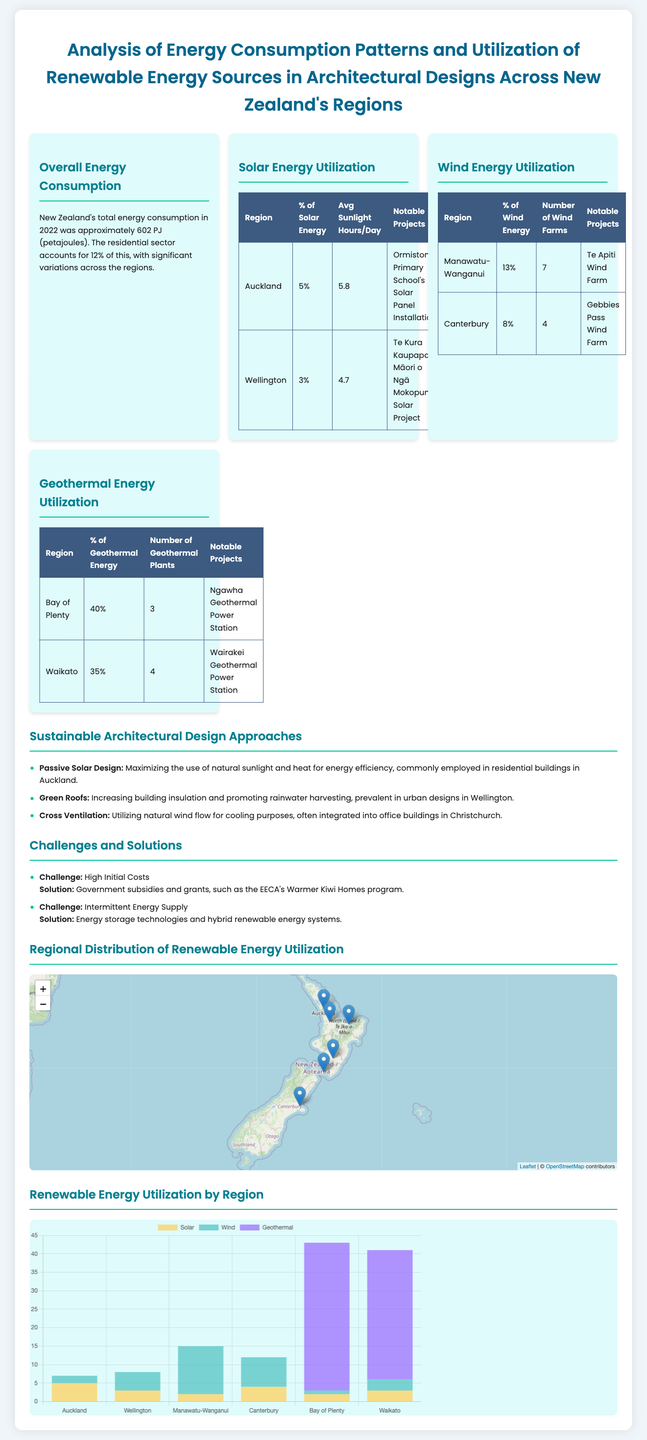what is the total energy consumption in New Zealand for 2022? The total energy consumption in New Zealand for 2022 was approximately 602 PJ.
Answer: 602 PJ what percentage of solar energy is utilized in Auckland? The table indicates that Auckland utilizes 5% of solar energy.
Answer: 5% which region has the highest percentage of geothermal energy utilization? The data shows that Bay of Plenty has the highest percentage of geothermal energy utilization at 40%.
Answer: 40% what notable project is mentioned for Wellington's solar energy utilization? The notable project mentioned for Wellington's solar energy utilization is Te Kura Kaupapa Māori o Ngā Mokopuna Solar Project.
Answer: Te Kura Kaupapa Māori o Ngā Mokopuna Solar Project how many wind farms are in Manawatu-Wanganui? The table states that there are 7 wind farms in Manawatu-Wanganui.
Answer: 7 which approach is emphasized under sustainable architectural design? The infographic lists Passive Solar Design as an emphasized approach in sustainable architectural design.
Answer: Passive Solar Design what is one solution noted for the challenge of high initial costs? The document notes that government subsidies and grants provide a solution to the challenge of high initial costs.
Answer: Government subsidies and grants how many geothermal plants are in Waikato? According to the table, there are 4 geothermal plants in Waikato.
Answer: 4 what color represents solar energy in the bar chart? In the bar chart, solar energy is represented by the color yellow (rgba(255, 206, 86, 0.7)).
Answer: Yellow 